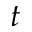Convert formula to latex. <formula><loc_0><loc_0><loc_500><loc_500>t</formula> 